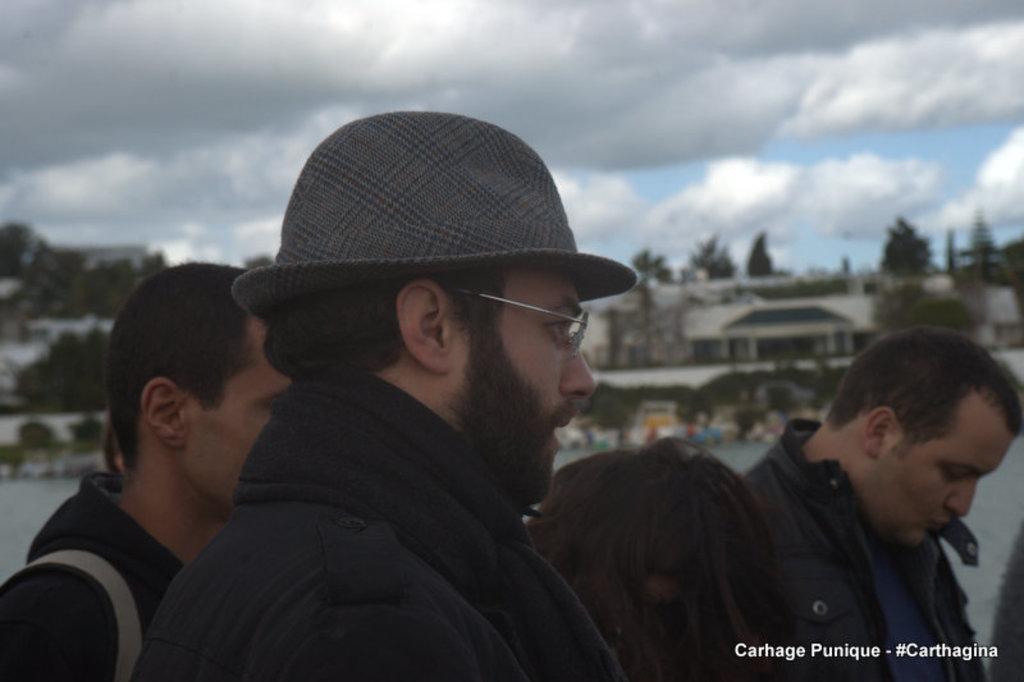What are the people in the image doing? The people in the image are standing together. What are the people wearing on their heads? The people are wearing hats. What type of natural environment is visible in the image? There are trees behind the people. What type of man-made structures can be seen in the background? There are buildings visible in the background. What type of cake is being served at the event in the image? There is no cake or event present in the image; it features people standing together with trees and buildings in the background. What type of seed is visible in the image? There is no seed visible in the image. 